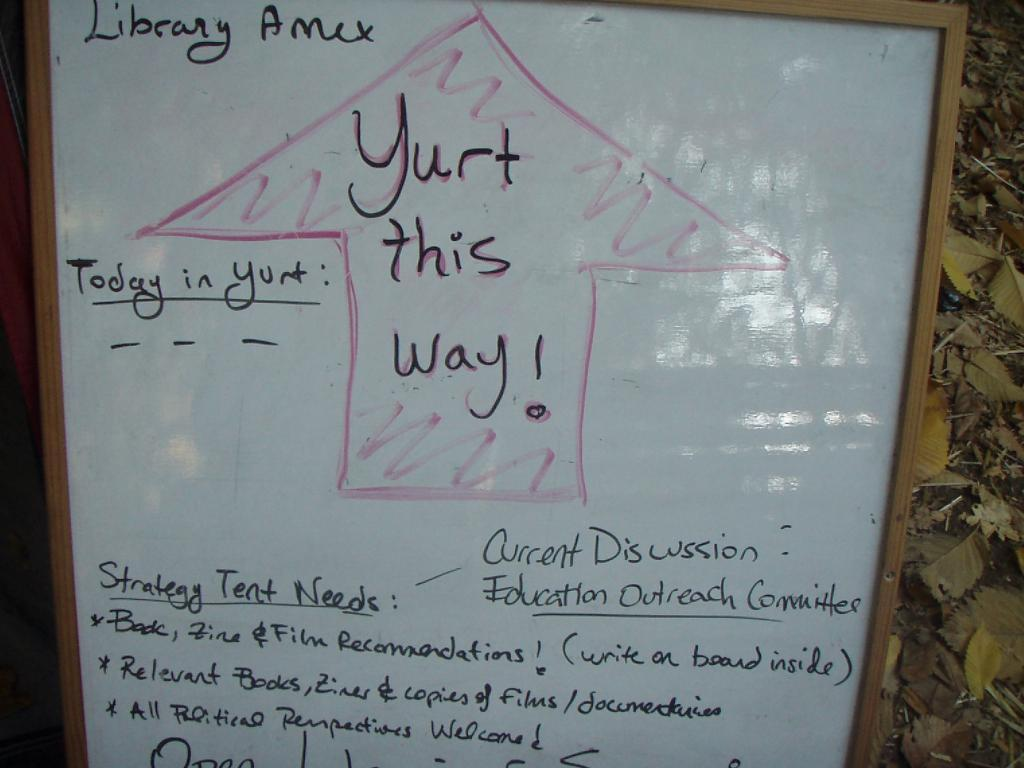What is the main object in the foreground of the image? There is a whiteboard in the foreground of the image. What can be seen on the whiteboard? There is text on the whiteboard. What type of natural elements are visible in the background of the image? There are leaves on the ground in the background of the image. What type of tail can be seen on the whiteboard in the image? There is no tail present on the whiteboard or in the image. 